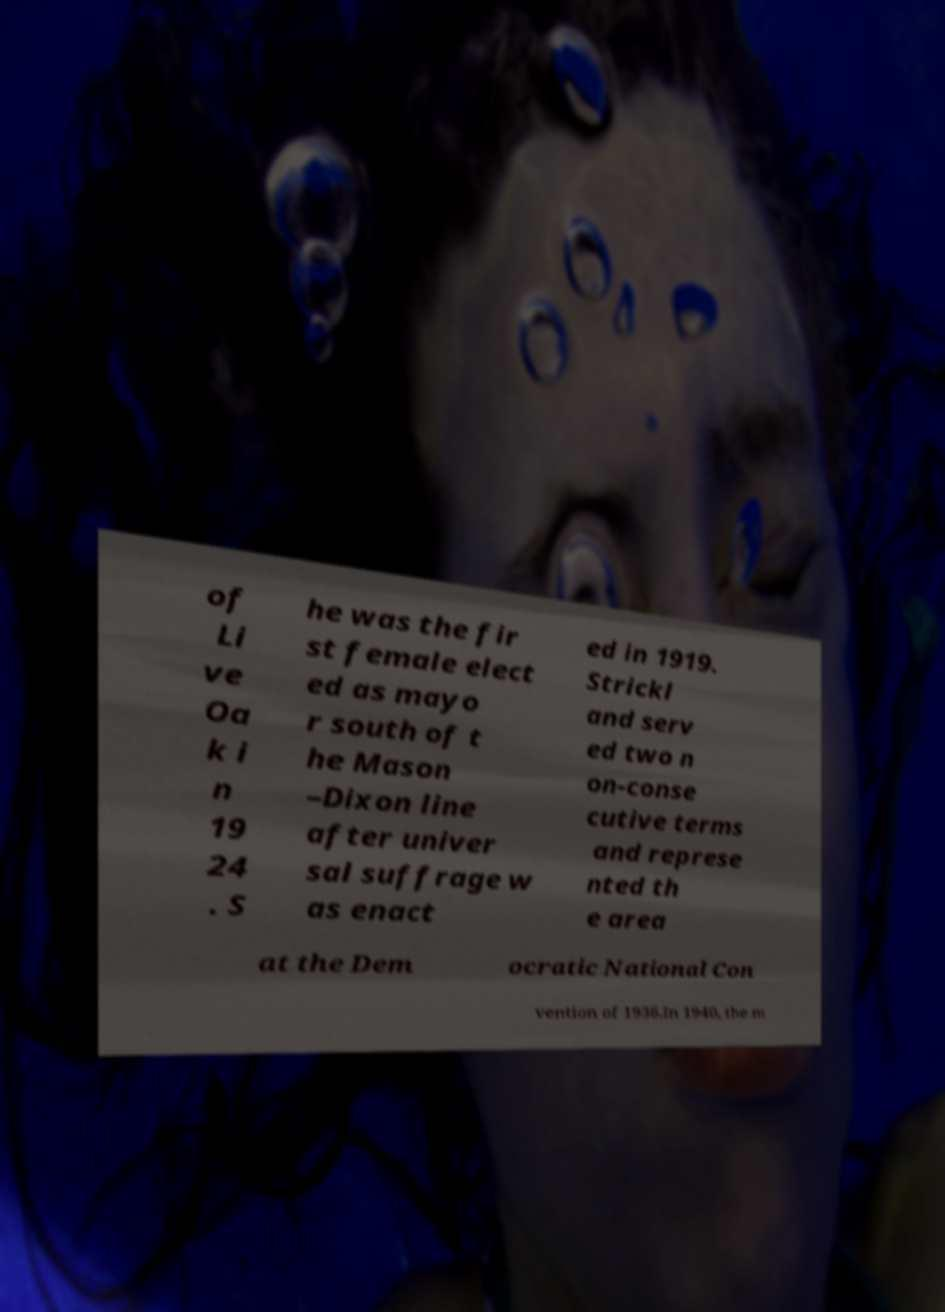What messages or text are displayed in this image? I need them in a readable, typed format. of Li ve Oa k i n 19 24 . S he was the fir st female elect ed as mayo r south of t he Mason –Dixon line after univer sal suffrage w as enact ed in 1919. Strickl and serv ed two n on-conse cutive terms and represe nted th e area at the Dem ocratic National Con vention of 1936.In 1940, the m 